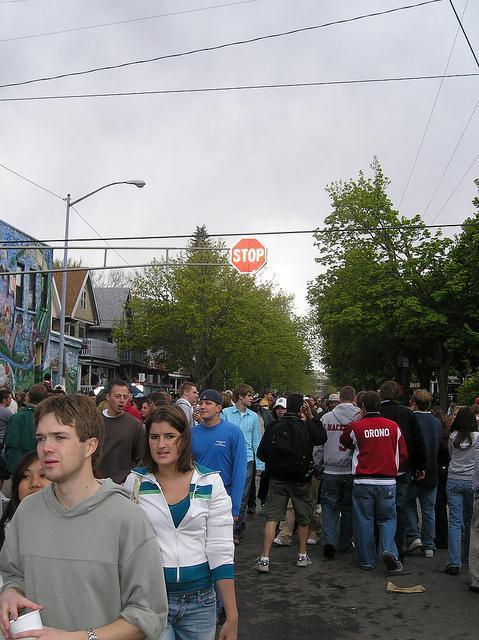How many street lights can be seen?
Give a very brief answer. 1. How many people can you see?
Give a very brief answer. 11. 